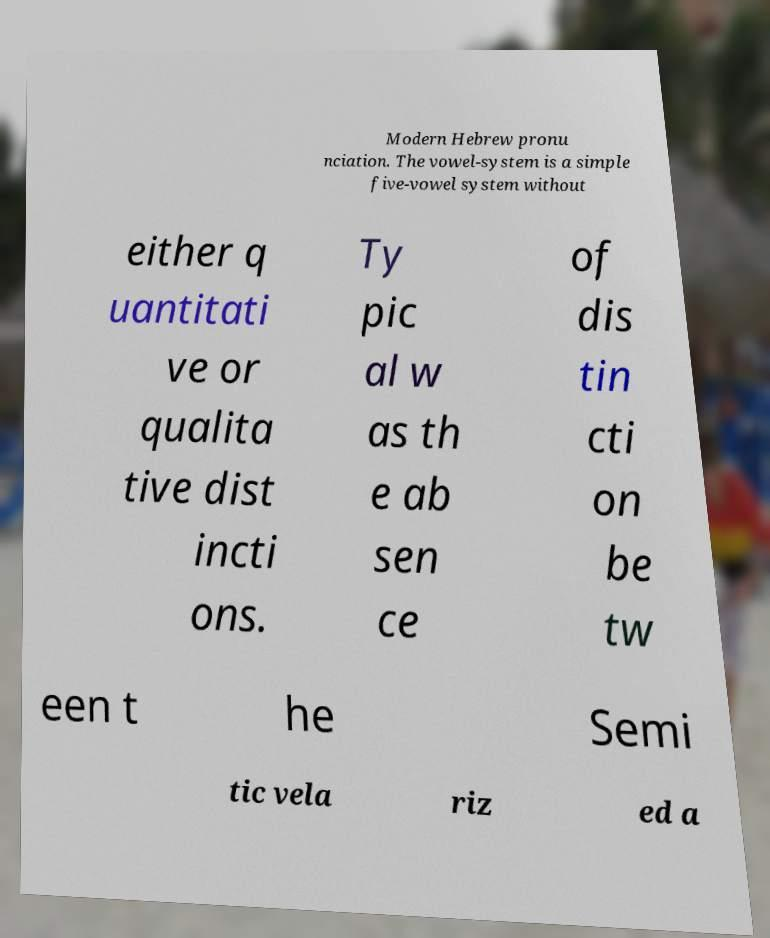Can you read and provide the text displayed in the image?This photo seems to have some interesting text. Can you extract and type it out for me? Modern Hebrew pronu nciation. The vowel-system is a simple five-vowel system without either q uantitati ve or qualita tive dist incti ons. Ty pic al w as th e ab sen ce of dis tin cti on be tw een t he Semi tic vela riz ed a 